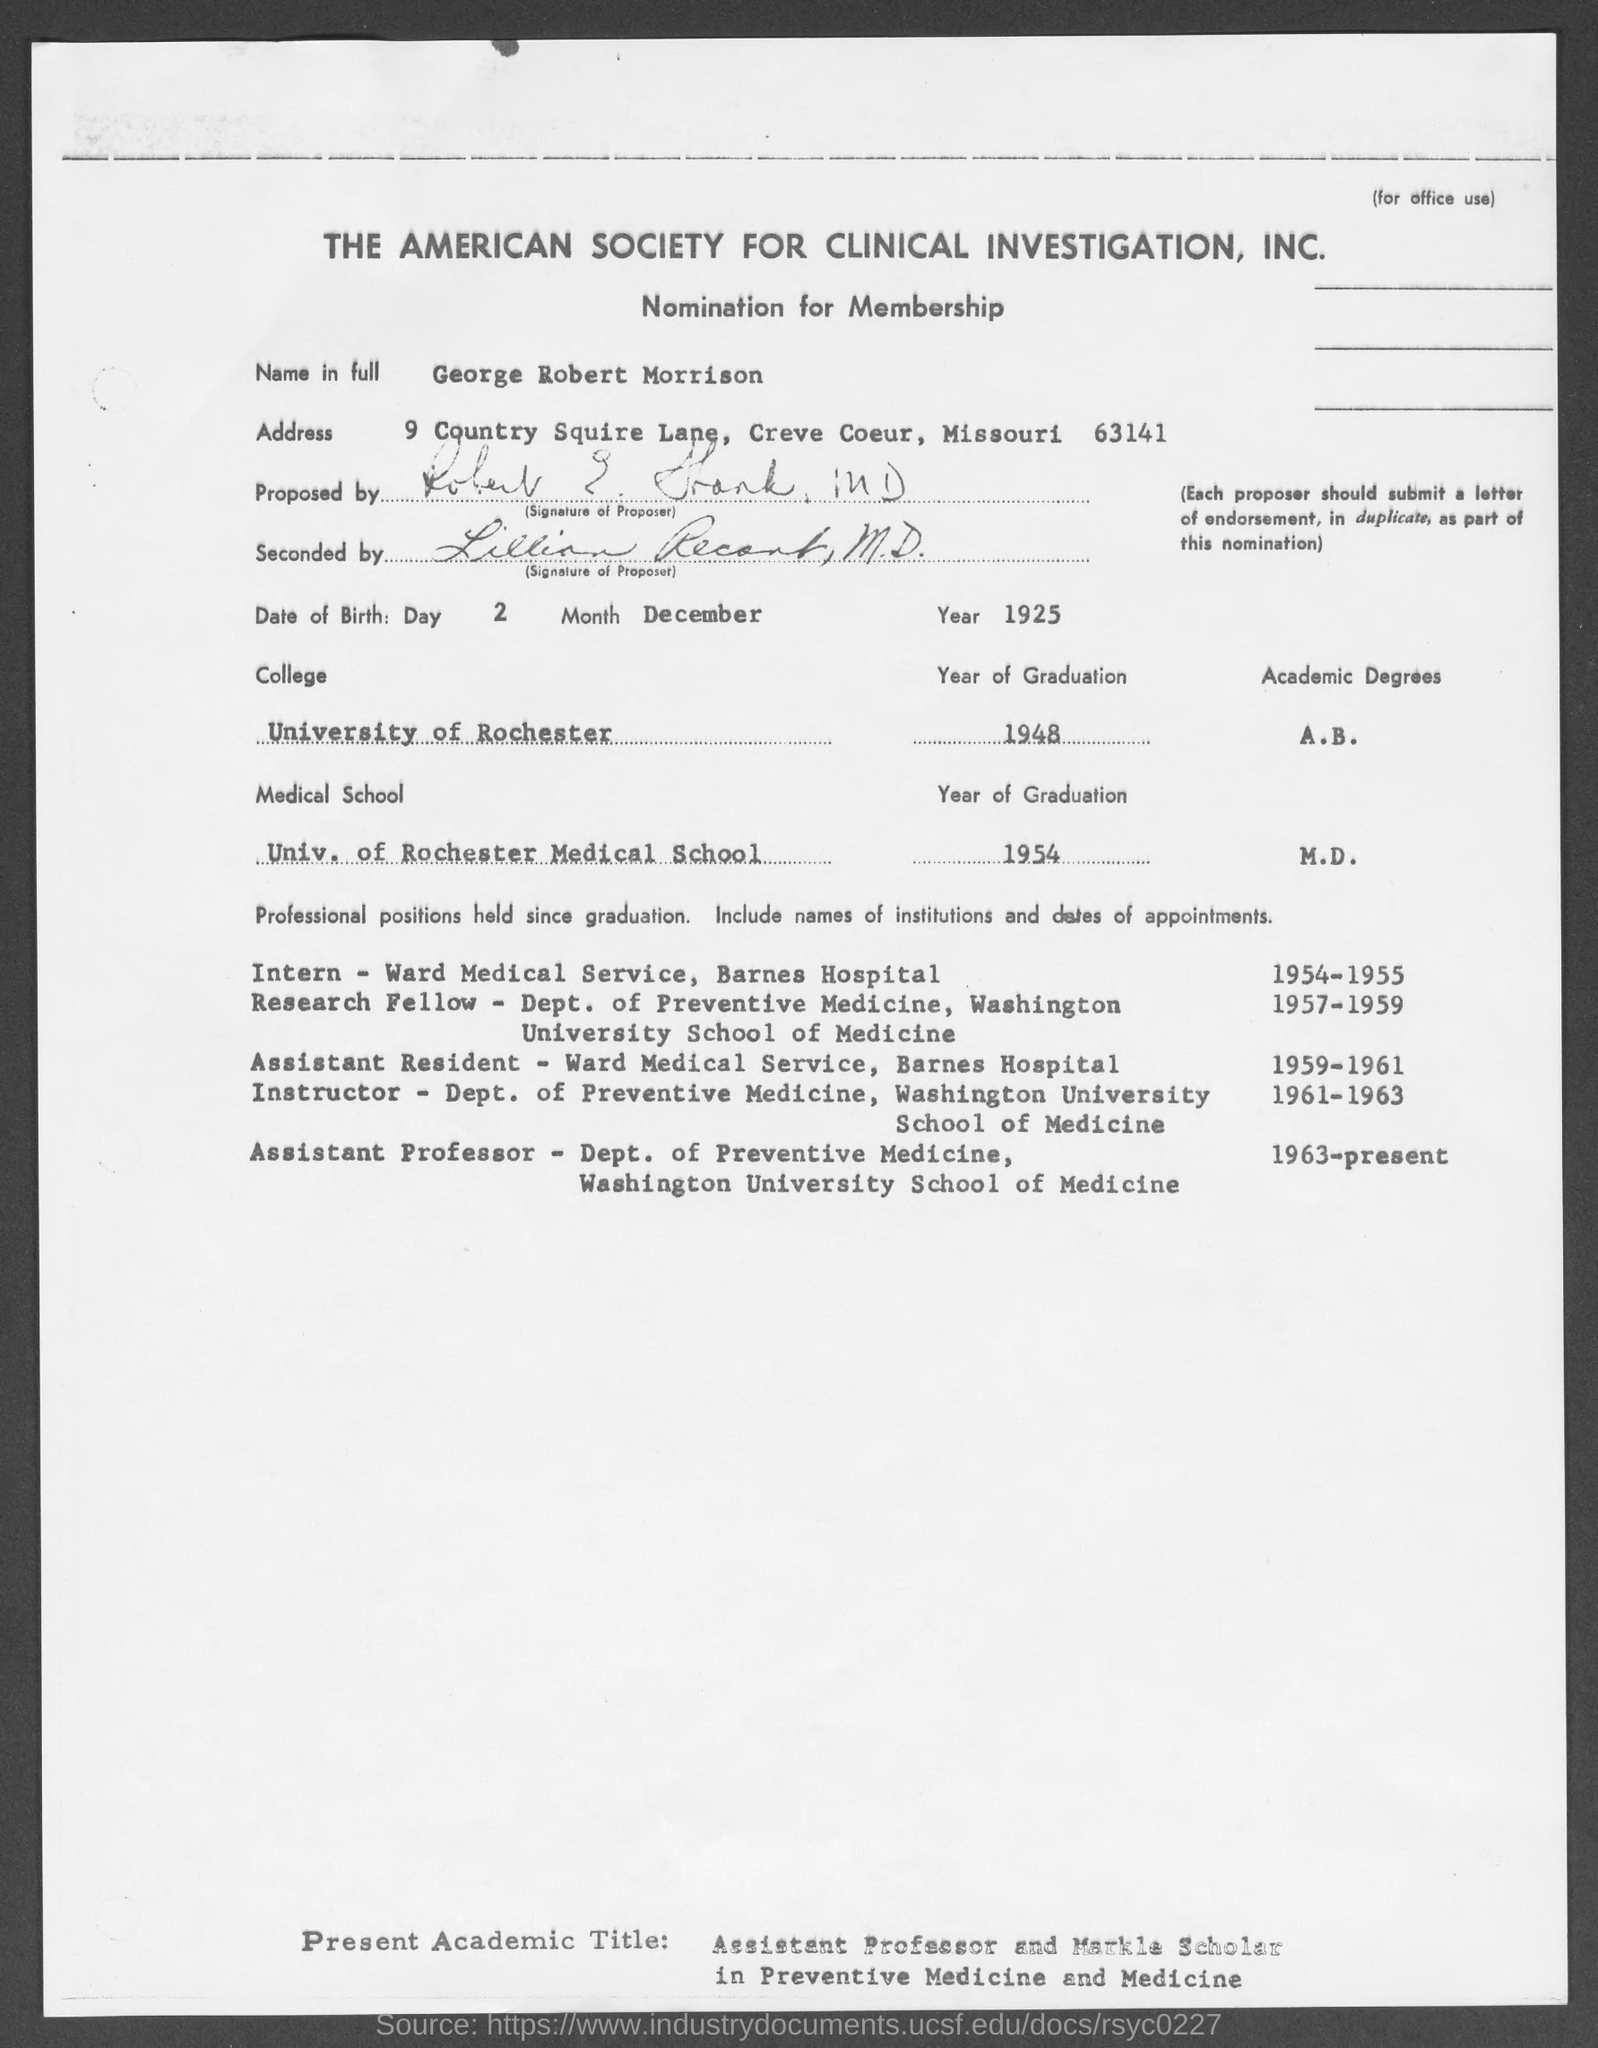Outline some significant characteristics in this image. I, George Robert Morrison, am willing to be nominated for membership. George completed his graduation from the University of Rochester in 1948, In the year 1954, George completed his graduation from the University of Rochester Medical School. 